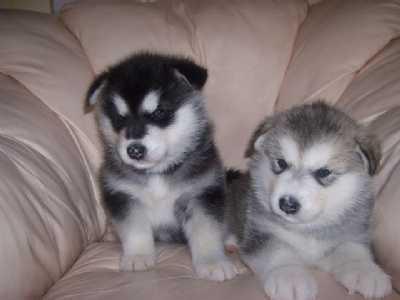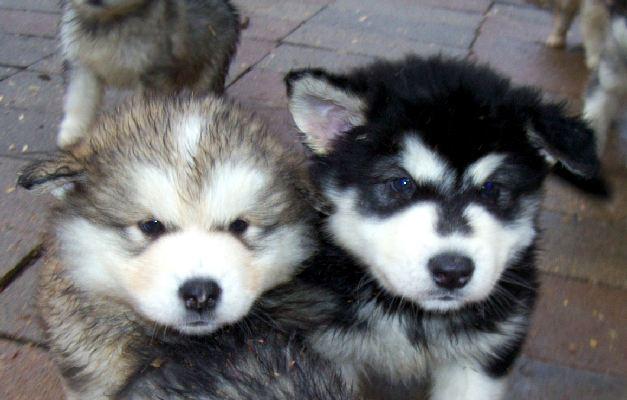The first image is the image on the left, the second image is the image on the right. Assess this claim about the two images: "There are three dogs". Correct or not? Answer yes or no. No. The first image is the image on the left, the second image is the image on the right. Evaluate the accuracy of this statement regarding the images: "All dogs are young husky puppies, the combined images include at least two black-and-white puppies, and one image shows a pair of puppies with all floppy ears, posed side-by-side and facing the camera.". Is it true? Answer yes or no. Yes. 